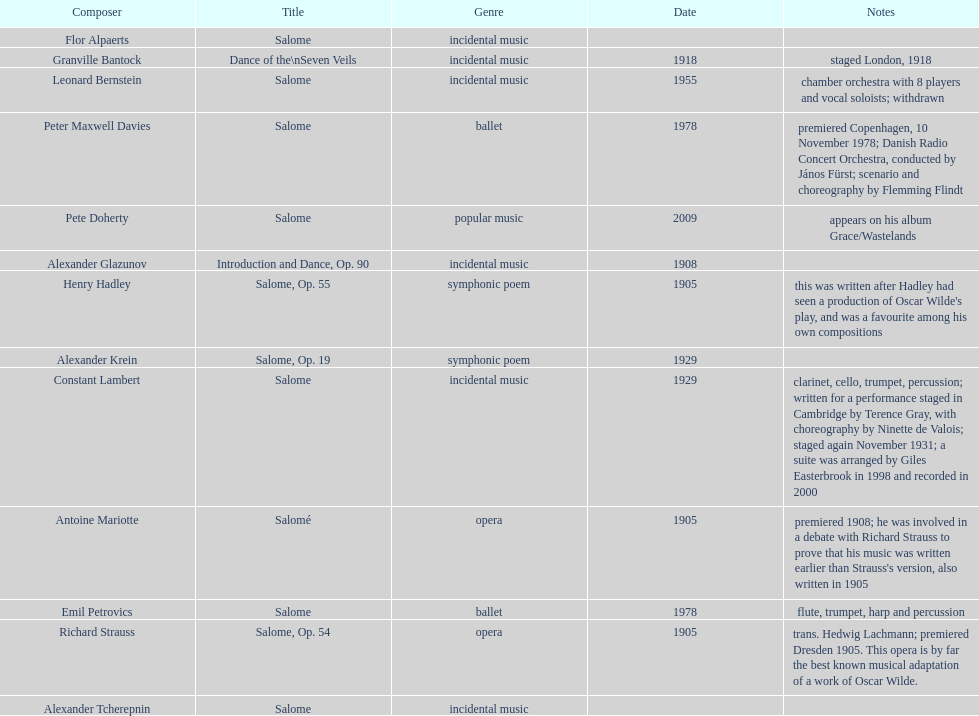Parse the table in full. {'header': ['Composer', 'Title', 'Genre', 'Date', 'Notes'], 'rows': [['Flor Alpaerts', 'Salome', 'incidental\xa0music', '', ''], ['Granville Bantock', 'Dance of the\\nSeven Veils', 'incidental music', '1918', 'staged London, 1918'], ['Leonard Bernstein', 'Salome', 'incidental music', '1955', 'chamber orchestra with 8 players and vocal soloists; withdrawn'], ['Peter\xa0Maxwell\xa0Davies', 'Salome', 'ballet', '1978', 'premiered Copenhagen, 10 November 1978; Danish Radio Concert Orchestra, conducted by János Fürst; scenario and choreography by Flemming Flindt'], ['Pete Doherty', 'Salome', 'popular music', '2009', 'appears on his album Grace/Wastelands'], ['Alexander Glazunov', 'Introduction and Dance, Op. 90', 'incidental music', '1908', ''], ['Henry Hadley', 'Salome, Op. 55', 'symphonic poem', '1905', "this was written after Hadley had seen a production of Oscar Wilde's play, and was a favourite among his own compositions"], ['Alexander Krein', 'Salome, Op. 19', 'symphonic poem', '1929', ''], ['Constant Lambert', 'Salome', 'incidental music', '1929', 'clarinet, cello, trumpet, percussion; written for a performance staged in Cambridge by Terence Gray, with choreography by Ninette de Valois; staged again November 1931; a suite was arranged by Giles Easterbrook in 1998 and recorded in 2000'], ['Antoine Mariotte', 'Salomé', 'opera', '1905', "premiered 1908; he was involved in a debate with Richard Strauss to prove that his music was written earlier than Strauss's version, also written in 1905"], ['Emil Petrovics', 'Salome', 'ballet', '1978', 'flute, trumpet, harp and percussion'], ['Richard Strauss', 'Salome, Op. 54', 'opera', '1905', 'trans. Hedwig Lachmann; premiered Dresden 1905. This opera is by far the best known musical adaptation of a work of Oscar Wilde.'], ['Alexander\xa0Tcherepnin', 'Salome', 'incidental music', '', '']]} Why type of genre was peter maxwell davies' work that was the same as emil petrovics' Ballet. 